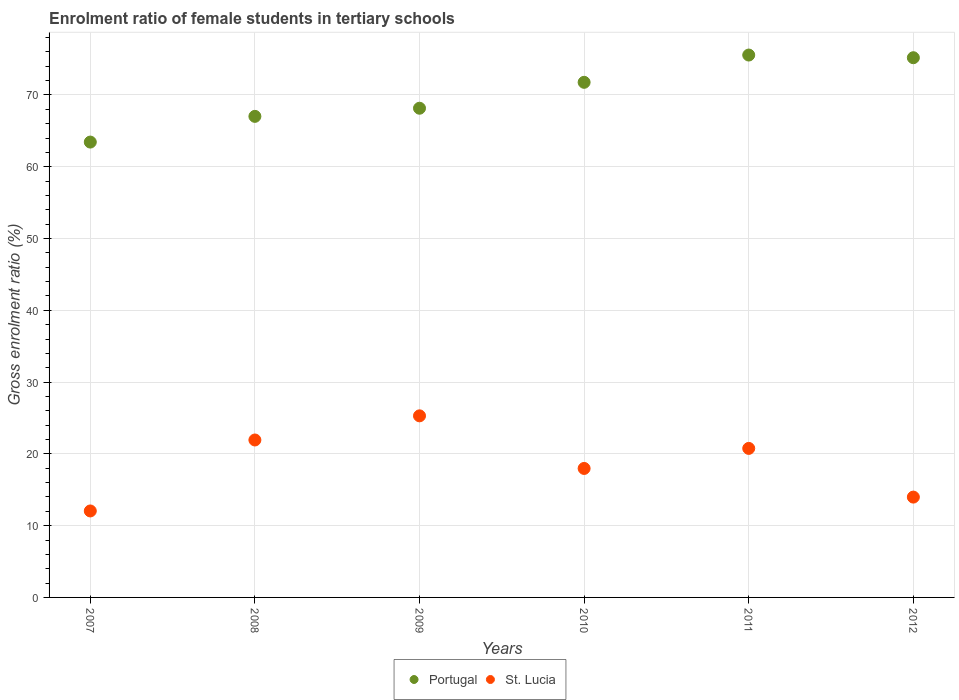How many different coloured dotlines are there?
Offer a very short reply. 2. Is the number of dotlines equal to the number of legend labels?
Offer a terse response. Yes. What is the enrolment ratio of female students in tertiary schools in St. Lucia in 2008?
Keep it short and to the point. 21.93. Across all years, what is the maximum enrolment ratio of female students in tertiary schools in Portugal?
Your answer should be compact. 75.56. Across all years, what is the minimum enrolment ratio of female students in tertiary schools in Portugal?
Provide a short and direct response. 63.44. In which year was the enrolment ratio of female students in tertiary schools in Portugal maximum?
Your answer should be compact. 2011. In which year was the enrolment ratio of female students in tertiary schools in St. Lucia minimum?
Your answer should be compact. 2007. What is the total enrolment ratio of female students in tertiary schools in St. Lucia in the graph?
Ensure brevity in your answer.  111.98. What is the difference between the enrolment ratio of female students in tertiary schools in Portugal in 2009 and that in 2010?
Give a very brief answer. -3.61. What is the difference between the enrolment ratio of female students in tertiary schools in St. Lucia in 2007 and the enrolment ratio of female students in tertiary schools in Portugal in 2009?
Your response must be concise. -56.1. What is the average enrolment ratio of female students in tertiary schools in St. Lucia per year?
Keep it short and to the point. 18.66. In the year 2012, what is the difference between the enrolment ratio of female students in tertiary schools in St. Lucia and enrolment ratio of female students in tertiary schools in Portugal?
Offer a terse response. -61.21. In how many years, is the enrolment ratio of female students in tertiary schools in St. Lucia greater than 24 %?
Provide a succinct answer. 1. What is the ratio of the enrolment ratio of female students in tertiary schools in Portugal in 2010 to that in 2012?
Ensure brevity in your answer.  0.95. Is the difference between the enrolment ratio of female students in tertiary schools in St. Lucia in 2008 and 2011 greater than the difference between the enrolment ratio of female students in tertiary schools in Portugal in 2008 and 2011?
Offer a very short reply. Yes. What is the difference between the highest and the second highest enrolment ratio of female students in tertiary schools in St. Lucia?
Your answer should be compact. 3.36. What is the difference between the highest and the lowest enrolment ratio of female students in tertiary schools in St. Lucia?
Provide a succinct answer. 13.25. Does the enrolment ratio of female students in tertiary schools in St. Lucia monotonically increase over the years?
Ensure brevity in your answer.  No. Is the enrolment ratio of female students in tertiary schools in Portugal strictly less than the enrolment ratio of female students in tertiary schools in St. Lucia over the years?
Your answer should be very brief. No. How many years are there in the graph?
Your response must be concise. 6. Does the graph contain grids?
Offer a terse response. Yes. Where does the legend appear in the graph?
Offer a terse response. Bottom center. How are the legend labels stacked?
Provide a succinct answer. Horizontal. What is the title of the graph?
Your answer should be very brief. Enrolment ratio of female students in tertiary schools. Does "East Asia (all income levels)" appear as one of the legend labels in the graph?
Provide a succinct answer. No. What is the label or title of the X-axis?
Offer a very short reply. Years. What is the label or title of the Y-axis?
Offer a terse response. Gross enrolment ratio (%). What is the Gross enrolment ratio (%) of Portugal in 2007?
Make the answer very short. 63.44. What is the Gross enrolment ratio (%) in St. Lucia in 2007?
Make the answer very short. 12.05. What is the Gross enrolment ratio (%) of Portugal in 2008?
Provide a short and direct response. 67.02. What is the Gross enrolment ratio (%) of St. Lucia in 2008?
Keep it short and to the point. 21.93. What is the Gross enrolment ratio (%) in Portugal in 2009?
Offer a very short reply. 68.15. What is the Gross enrolment ratio (%) in St. Lucia in 2009?
Ensure brevity in your answer.  25.3. What is the Gross enrolment ratio (%) in Portugal in 2010?
Your answer should be very brief. 71.76. What is the Gross enrolment ratio (%) in St. Lucia in 2010?
Offer a very short reply. 17.97. What is the Gross enrolment ratio (%) of Portugal in 2011?
Your answer should be very brief. 75.56. What is the Gross enrolment ratio (%) in St. Lucia in 2011?
Provide a succinct answer. 20.76. What is the Gross enrolment ratio (%) in Portugal in 2012?
Make the answer very short. 75.19. What is the Gross enrolment ratio (%) of St. Lucia in 2012?
Make the answer very short. 13.98. Across all years, what is the maximum Gross enrolment ratio (%) in Portugal?
Your response must be concise. 75.56. Across all years, what is the maximum Gross enrolment ratio (%) in St. Lucia?
Offer a very short reply. 25.3. Across all years, what is the minimum Gross enrolment ratio (%) in Portugal?
Your answer should be very brief. 63.44. Across all years, what is the minimum Gross enrolment ratio (%) in St. Lucia?
Make the answer very short. 12.05. What is the total Gross enrolment ratio (%) of Portugal in the graph?
Keep it short and to the point. 421.11. What is the total Gross enrolment ratio (%) of St. Lucia in the graph?
Make the answer very short. 111.98. What is the difference between the Gross enrolment ratio (%) of Portugal in 2007 and that in 2008?
Your answer should be compact. -3.58. What is the difference between the Gross enrolment ratio (%) of St. Lucia in 2007 and that in 2008?
Offer a terse response. -9.89. What is the difference between the Gross enrolment ratio (%) of Portugal in 2007 and that in 2009?
Your answer should be compact. -4.71. What is the difference between the Gross enrolment ratio (%) of St. Lucia in 2007 and that in 2009?
Keep it short and to the point. -13.25. What is the difference between the Gross enrolment ratio (%) in Portugal in 2007 and that in 2010?
Ensure brevity in your answer.  -8.32. What is the difference between the Gross enrolment ratio (%) of St. Lucia in 2007 and that in 2010?
Provide a succinct answer. -5.92. What is the difference between the Gross enrolment ratio (%) in Portugal in 2007 and that in 2011?
Provide a short and direct response. -12.12. What is the difference between the Gross enrolment ratio (%) in St. Lucia in 2007 and that in 2011?
Your answer should be very brief. -8.71. What is the difference between the Gross enrolment ratio (%) of Portugal in 2007 and that in 2012?
Offer a very short reply. -11.75. What is the difference between the Gross enrolment ratio (%) of St. Lucia in 2007 and that in 2012?
Offer a terse response. -1.93. What is the difference between the Gross enrolment ratio (%) in Portugal in 2008 and that in 2009?
Give a very brief answer. -1.13. What is the difference between the Gross enrolment ratio (%) in St. Lucia in 2008 and that in 2009?
Offer a terse response. -3.36. What is the difference between the Gross enrolment ratio (%) of Portugal in 2008 and that in 2010?
Provide a succinct answer. -4.74. What is the difference between the Gross enrolment ratio (%) of St. Lucia in 2008 and that in 2010?
Provide a short and direct response. 3.96. What is the difference between the Gross enrolment ratio (%) of Portugal in 2008 and that in 2011?
Your answer should be very brief. -8.54. What is the difference between the Gross enrolment ratio (%) in St. Lucia in 2008 and that in 2011?
Ensure brevity in your answer.  1.17. What is the difference between the Gross enrolment ratio (%) of Portugal in 2008 and that in 2012?
Offer a very short reply. -8.17. What is the difference between the Gross enrolment ratio (%) in St. Lucia in 2008 and that in 2012?
Your answer should be compact. 7.96. What is the difference between the Gross enrolment ratio (%) in Portugal in 2009 and that in 2010?
Your answer should be compact. -3.61. What is the difference between the Gross enrolment ratio (%) in St. Lucia in 2009 and that in 2010?
Provide a short and direct response. 7.33. What is the difference between the Gross enrolment ratio (%) in Portugal in 2009 and that in 2011?
Your response must be concise. -7.41. What is the difference between the Gross enrolment ratio (%) of St. Lucia in 2009 and that in 2011?
Your answer should be compact. 4.54. What is the difference between the Gross enrolment ratio (%) in Portugal in 2009 and that in 2012?
Your answer should be very brief. -7.04. What is the difference between the Gross enrolment ratio (%) of St. Lucia in 2009 and that in 2012?
Your answer should be compact. 11.32. What is the difference between the Gross enrolment ratio (%) in Portugal in 2010 and that in 2011?
Provide a succinct answer. -3.8. What is the difference between the Gross enrolment ratio (%) in St. Lucia in 2010 and that in 2011?
Your answer should be very brief. -2.79. What is the difference between the Gross enrolment ratio (%) in Portugal in 2010 and that in 2012?
Your response must be concise. -3.43. What is the difference between the Gross enrolment ratio (%) in St. Lucia in 2010 and that in 2012?
Provide a succinct answer. 3.99. What is the difference between the Gross enrolment ratio (%) in Portugal in 2011 and that in 2012?
Keep it short and to the point. 0.37. What is the difference between the Gross enrolment ratio (%) in St. Lucia in 2011 and that in 2012?
Keep it short and to the point. 6.78. What is the difference between the Gross enrolment ratio (%) in Portugal in 2007 and the Gross enrolment ratio (%) in St. Lucia in 2008?
Offer a terse response. 41.5. What is the difference between the Gross enrolment ratio (%) of Portugal in 2007 and the Gross enrolment ratio (%) of St. Lucia in 2009?
Give a very brief answer. 38.14. What is the difference between the Gross enrolment ratio (%) in Portugal in 2007 and the Gross enrolment ratio (%) in St. Lucia in 2010?
Your answer should be very brief. 45.47. What is the difference between the Gross enrolment ratio (%) in Portugal in 2007 and the Gross enrolment ratio (%) in St. Lucia in 2011?
Keep it short and to the point. 42.68. What is the difference between the Gross enrolment ratio (%) of Portugal in 2007 and the Gross enrolment ratio (%) of St. Lucia in 2012?
Keep it short and to the point. 49.46. What is the difference between the Gross enrolment ratio (%) of Portugal in 2008 and the Gross enrolment ratio (%) of St. Lucia in 2009?
Keep it short and to the point. 41.72. What is the difference between the Gross enrolment ratio (%) of Portugal in 2008 and the Gross enrolment ratio (%) of St. Lucia in 2010?
Your answer should be very brief. 49.05. What is the difference between the Gross enrolment ratio (%) in Portugal in 2008 and the Gross enrolment ratio (%) in St. Lucia in 2011?
Your response must be concise. 46.26. What is the difference between the Gross enrolment ratio (%) of Portugal in 2008 and the Gross enrolment ratio (%) of St. Lucia in 2012?
Give a very brief answer. 53.04. What is the difference between the Gross enrolment ratio (%) in Portugal in 2009 and the Gross enrolment ratio (%) in St. Lucia in 2010?
Ensure brevity in your answer.  50.18. What is the difference between the Gross enrolment ratio (%) of Portugal in 2009 and the Gross enrolment ratio (%) of St. Lucia in 2011?
Your answer should be very brief. 47.39. What is the difference between the Gross enrolment ratio (%) of Portugal in 2009 and the Gross enrolment ratio (%) of St. Lucia in 2012?
Ensure brevity in your answer.  54.17. What is the difference between the Gross enrolment ratio (%) of Portugal in 2010 and the Gross enrolment ratio (%) of St. Lucia in 2012?
Offer a very short reply. 57.78. What is the difference between the Gross enrolment ratio (%) in Portugal in 2011 and the Gross enrolment ratio (%) in St. Lucia in 2012?
Keep it short and to the point. 61.58. What is the average Gross enrolment ratio (%) in Portugal per year?
Provide a succinct answer. 70.19. What is the average Gross enrolment ratio (%) in St. Lucia per year?
Your answer should be very brief. 18.66. In the year 2007, what is the difference between the Gross enrolment ratio (%) of Portugal and Gross enrolment ratio (%) of St. Lucia?
Give a very brief answer. 51.39. In the year 2008, what is the difference between the Gross enrolment ratio (%) of Portugal and Gross enrolment ratio (%) of St. Lucia?
Your answer should be very brief. 45.08. In the year 2009, what is the difference between the Gross enrolment ratio (%) in Portugal and Gross enrolment ratio (%) in St. Lucia?
Your answer should be very brief. 42.85. In the year 2010, what is the difference between the Gross enrolment ratio (%) in Portugal and Gross enrolment ratio (%) in St. Lucia?
Your answer should be very brief. 53.79. In the year 2011, what is the difference between the Gross enrolment ratio (%) of Portugal and Gross enrolment ratio (%) of St. Lucia?
Give a very brief answer. 54.8. In the year 2012, what is the difference between the Gross enrolment ratio (%) in Portugal and Gross enrolment ratio (%) in St. Lucia?
Provide a succinct answer. 61.21. What is the ratio of the Gross enrolment ratio (%) in Portugal in 2007 to that in 2008?
Your response must be concise. 0.95. What is the ratio of the Gross enrolment ratio (%) of St. Lucia in 2007 to that in 2008?
Your response must be concise. 0.55. What is the ratio of the Gross enrolment ratio (%) of Portugal in 2007 to that in 2009?
Your answer should be very brief. 0.93. What is the ratio of the Gross enrolment ratio (%) in St. Lucia in 2007 to that in 2009?
Make the answer very short. 0.48. What is the ratio of the Gross enrolment ratio (%) in Portugal in 2007 to that in 2010?
Provide a short and direct response. 0.88. What is the ratio of the Gross enrolment ratio (%) in St. Lucia in 2007 to that in 2010?
Your response must be concise. 0.67. What is the ratio of the Gross enrolment ratio (%) in Portugal in 2007 to that in 2011?
Keep it short and to the point. 0.84. What is the ratio of the Gross enrolment ratio (%) of St. Lucia in 2007 to that in 2011?
Provide a short and direct response. 0.58. What is the ratio of the Gross enrolment ratio (%) in Portugal in 2007 to that in 2012?
Keep it short and to the point. 0.84. What is the ratio of the Gross enrolment ratio (%) of St. Lucia in 2007 to that in 2012?
Keep it short and to the point. 0.86. What is the ratio of the Gross enrolment ratio (%) in Portugal in 2008 to that in 2009?
Your answer should be very brief. 0.98. What is the ratio of the Gross enrolment ratio (%) in St. Lucia in 2008 to that in 2009?
Your answer should be very brief. 0.87. What is the ratio of the Gross enrolment ratio (%) in Portugal in 2008 to that in 2010?
Make the answer very short. 0.93. What is the ratio of the Gross enrolment ratio (%) of St. Lucia in 2008 to that in 2010?
Offer a terse response. 1.22. What is the ratio of the Gross enrolment ratio (%) of Portugal in 2008 to that in 2011?
Provide a succinct answer. 0.89. What is the ratio of the Gross enrolment ratio (%) in St. Lucia in 2008 to that in 2011?
Keep it short and to the point. 1.06. What is the ratio of the Gross enrolment ratio (%) in Portugal in 2008 to that in 2012?
Provide a short and direct response. 0.89. What is the ratio of the Gross enrolment ratio (%) of St. Lucia in 2008 to that in 2012?
Offer a very short reply. 1.57. What is the ratio of the Gross enrolment ratio (%) of Portugal in 2009 to that in 2010?
Give a very brief answer. 0.95. What is the ratio of the Gross enrolment ratio (%) of St. Lucia in 2009 to that in 2010?
Offer a very short reply. 1.41. What is the ratio of the Gross enrolment ratio (%) in Portugal in 2009 to that in 2011?
Provide a succinct answer. 0.9. What is the ratio of the Gross enrolment ratio (%) of St. Lucia in 2009 to that in 2011?
Provide a short and direct response. 1.22. What is the ratio of the Gross enrolment ratio (%) in Portugal in 2009 to that in 2012?
Ensure brevity in your answer.  0.91. What is the ratio of the Gross enrolment ratio (%) of St. Lucia in 2009 to that in 2012?
Offer a terse response. 1.81. What is the ratio of the Gross enrolment ratio (%) of Portugal in 2010 to that in 2011?
Ensure brevity in your answer.  0.95. What is the ratio of the Gross enrolment ratio (%) in St. Lucia in 2010 to that in 2011?
Offer a terse response. 0.87. What is the ratio of the Gross enrolment ratio (%) in Portugal in 2010 to that in 2012?
Your answer should be very brief. 0.95. What is the ratio of the Gross enrolment ratio (%) in St. Lucia in 2010 to that in 2012?
Provide a succinct answer. 1.29. What is the ratio of the Gross enrolment ratio (%) of St. Lucia in 2011 to that in 2012?
Provide a succinct answer. 1.49. What is the difference between the highest and the second highest Gross enrolment ratio (%) in Portugal?
Keep it short and to the point. 0.37. What is the difference between the highest and the second highest Gross enrolment ratio (%) in St. Lucia?
Your response must be concise. 3.36. What is the difference between the highest and the lowest Gross enrolment ratio (%) in Portugal?
Your answer should be compact. 12.12. What is the difference between the highest and the lowest Gross enrolment ratio (%) in St. Lucia?
Your response must be concise. 13.25. 